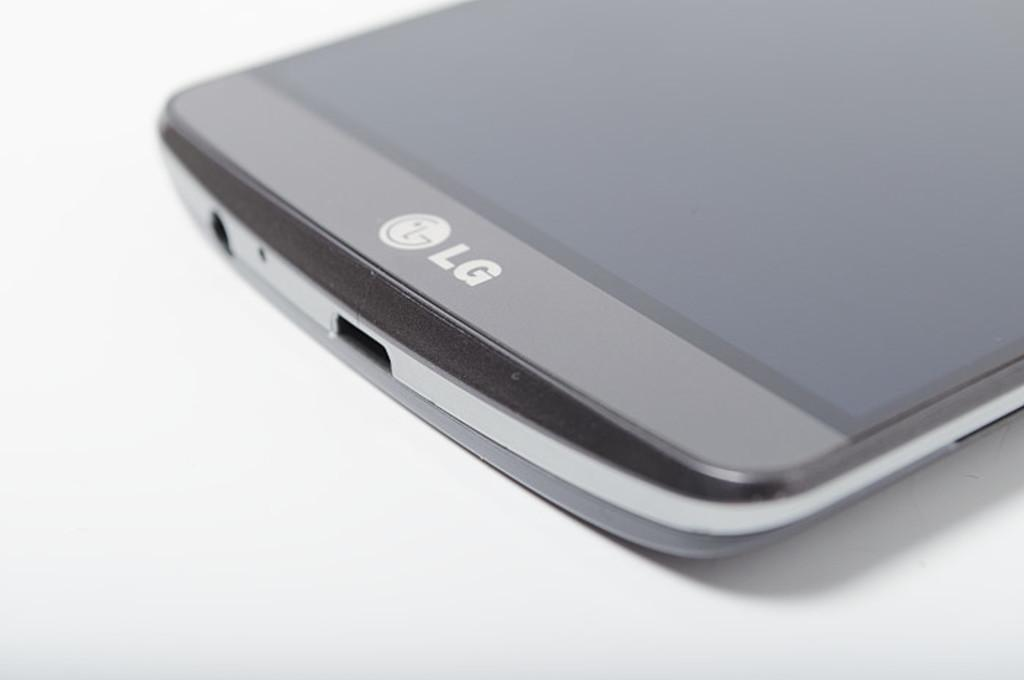Provide a one-sentence caption for the provided image. A grey LG phone lays on a white surface, only the bottom half visible. 